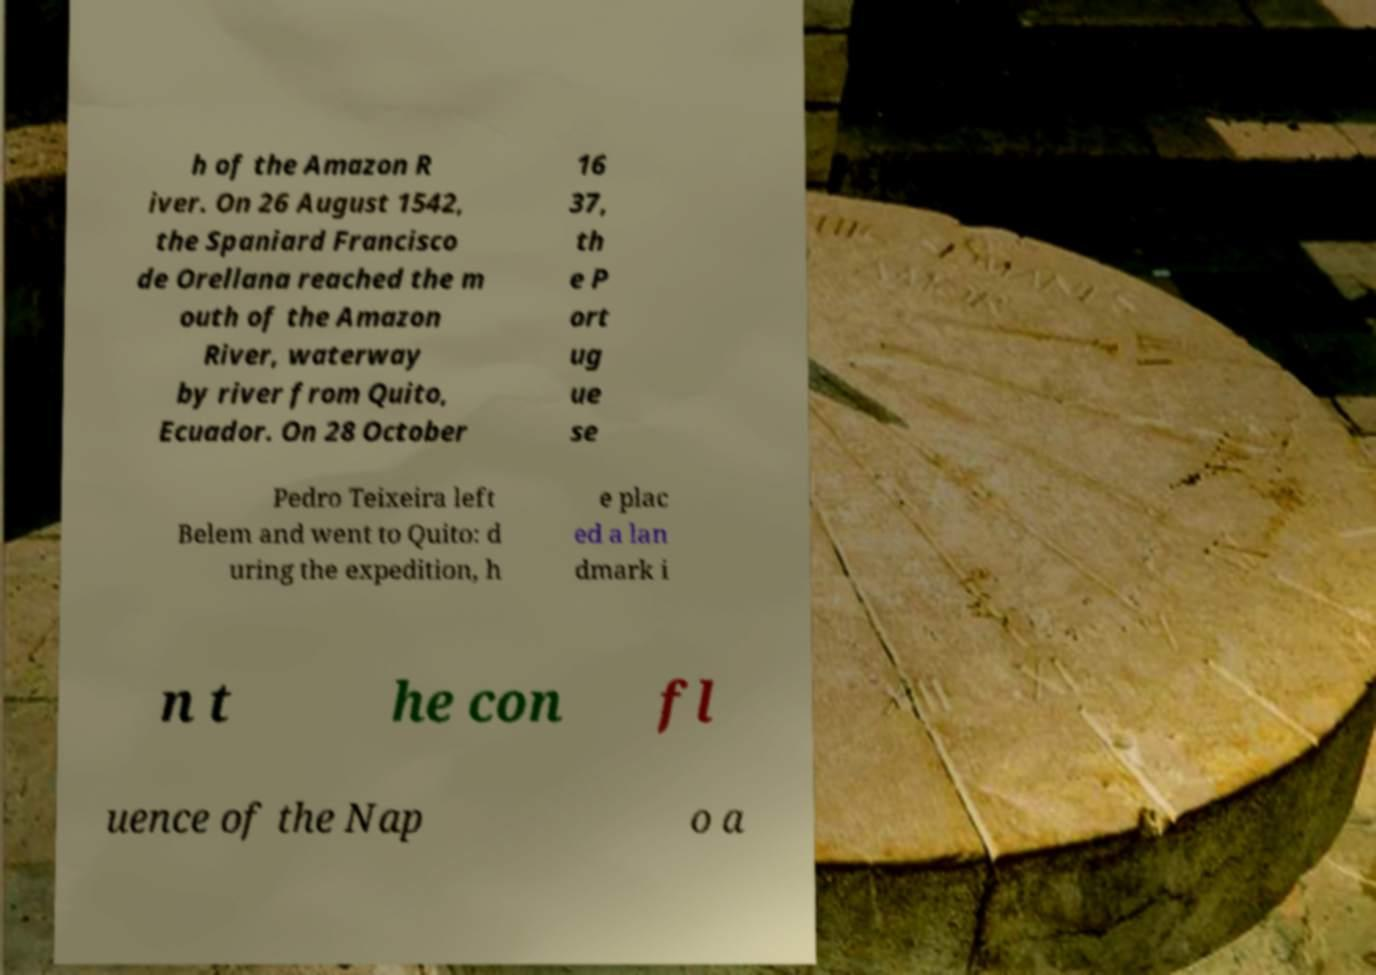For documentation purposes, I need the text within this image transcribed. Could you provide that? h of the Amazon R iver. On 26 August 1542, the Spaniard Francisco de Orellana reached the m outh of the Amazon River, waterway by river from Quito, Ecuador. On 28 October 16 37, th e P ort ug ue se Pedro Teixeira left Belem and went to Quito: d uring the expedition, h e plac ed a lan dmark i n t he con fl uence of the Nap o a 